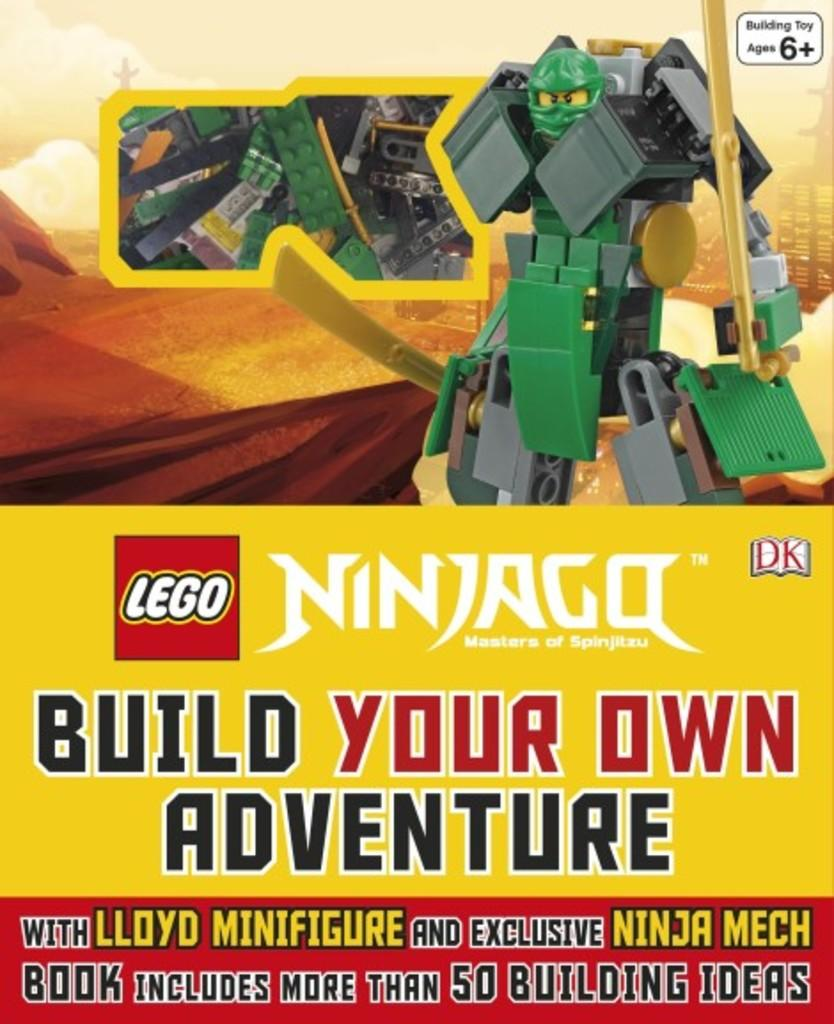<image>
Create a compact narrative representing the image presented. A box cover for Lego toy featuring Ninjago for kids ages 6 and over. 